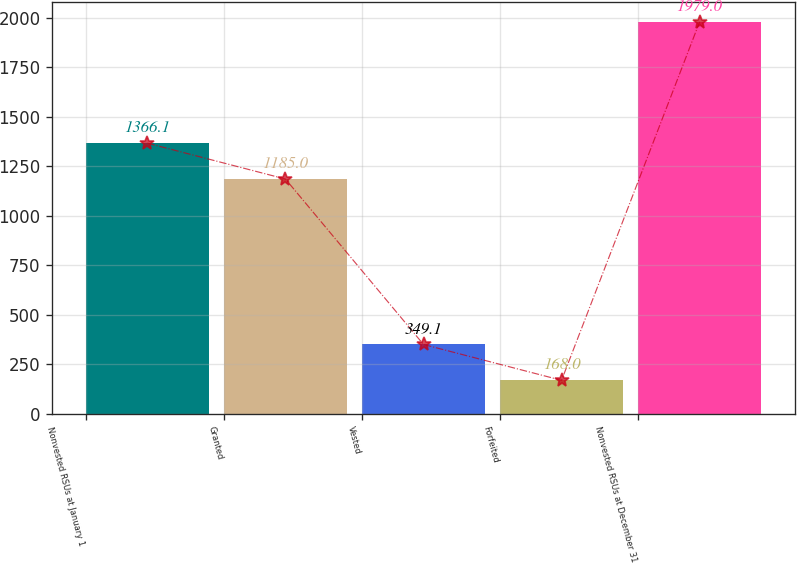Convert chart. <chart><loc_0><loc_0><loc_500><loc_500><bar_chart><fcel>Nonvested RSUs at January 1<fcel>Granted<fcel>Vested<fcel>Forfeited<fcel>Nonvested RSUs at December 31<nl><fcel>1366.1<fcel>1185<fcel>349.1<fcel>168<fcel>1979<nl></chart> 